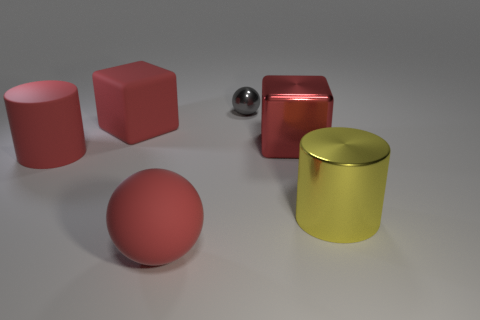Is the color of the large shiny cube the same as the large rubber sphere?
Your answer should be compact. Yes. What number of things are the same size as the shiny cube?
Keep it short and to the point. 4. There is a red block to the right of the rubber block; is there a large rubber cube that is left of it?
Your answer should be compact. Yes. What number of red objects are big cylinders or matte objects?
Make the answer very short. 3. What color is the large rubber cube?
Your response must be concise. Red. What size is the red cube that is made of the same material as the red cylinder?
Make the answer very short. Large. What number of other metallic things have the same shape as the small metallic object?
Make the answer very short. 0. Are there any other things that are the same size as the gray sphere?
Your answer should be very brief. No. There is a cube behind the big metal object behind the red cylinder; how big is it?
Offer a very short reply. Large. What is the material of the other cylinder that is the same size as the matte cylinder?
Your response must be concise. Metal. 